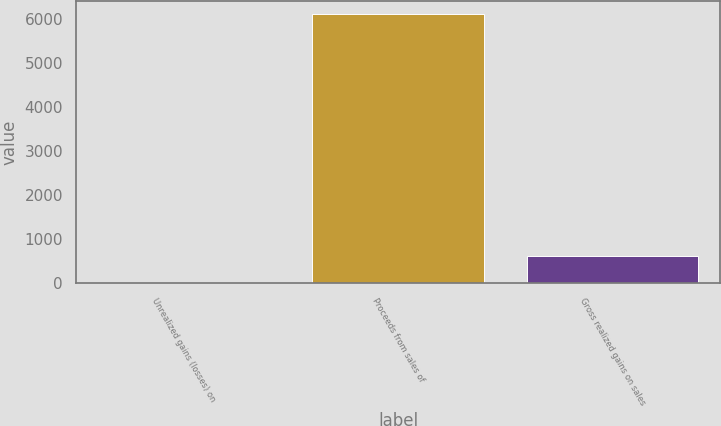<chart> <loc_0><loc_0><loc_500><loc_500><bar_chart><fcel>Unrealized gains (losses) on<fcel>Proceeds from sales of<fcel>Gross realized gains on sales<nl><fcel>2<fcel>6119<fcel>613.7<nl></chart> 